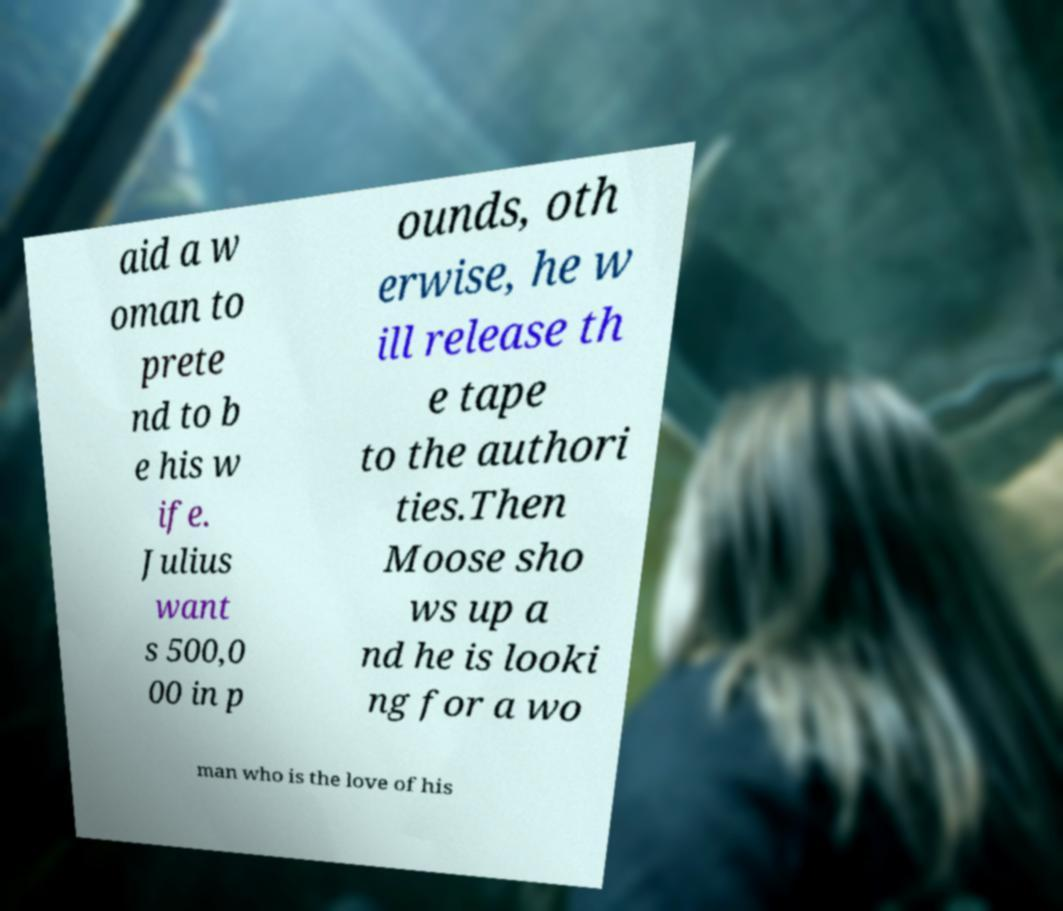Can you accurately transcribe the text from the provided image for me? aid a w oman to prete nd to b e his w ife. Julius want s 500,0 00 in p ounds, oth erwise, he w ill release th e tape to the authori ties.Then Moose sho ws up a nd he is looki ng for a wo man who is the love of his 